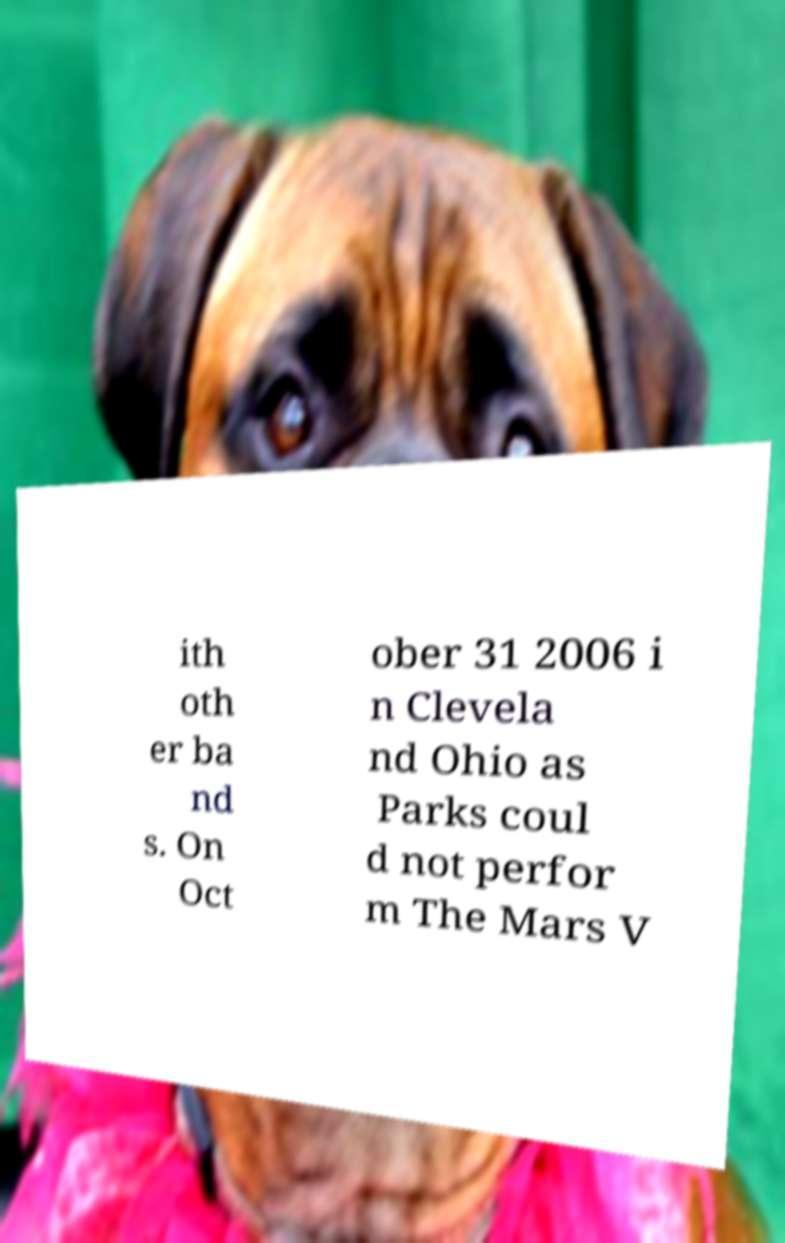Could you assist in decoding the text presented in this image and type it out clearly? ith oth er ba nd s. On Oct ober 31 2006 i n Clevela nd Ohio as Parks coul d not perfor m The Mars V 